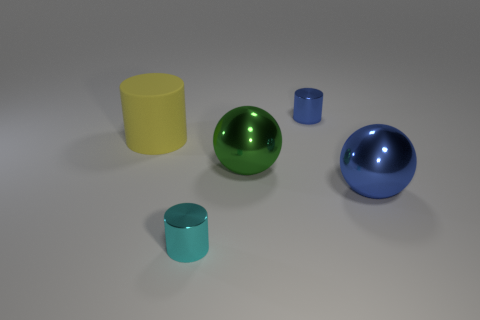Subtract all blue cylinders. How many cylinders are left? 2 Add 3 tiny green metal balls. How many objects exist? 8 Subtract all blue balls. How many balls are left? 1 Subtract 2 balls. How many balls are left? 0 Subtract all matte things. Subtract all shiny cylinders. How many objects are left? 2 Add 3 green shiny balls. How many green shiny balls are left? 4 Add 5 large blue metal cubes. How many large blue metal cubes exist? 5 Subtract 0 green cylinders. How many objects are left? 5 Subtract all balls. How many objects are left? 3 Subtract all gray spheres. Subtract all green cylinders. How many spheres are left? 2 